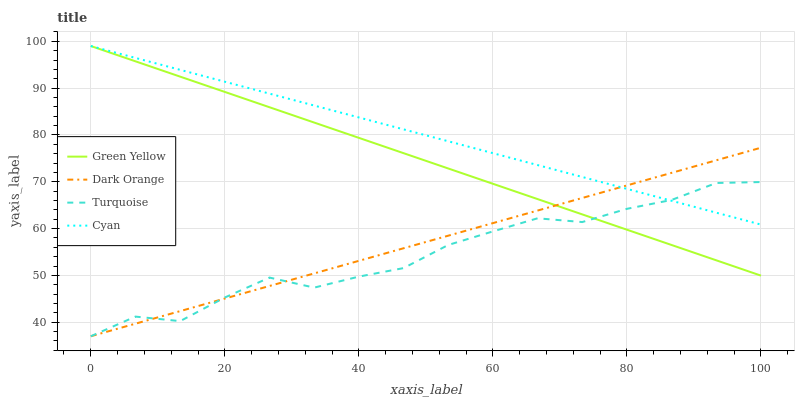Does Turquoise have the minimum area under the curve?
Answer yes or no. Yes. Does Cyan have the maximum area under the curve?
Answer yes or no. Yes. Does Green Yellow have the minimum area under the curve?
Answer yes or no. No. Does Green Yellow have the maximum area under the curve?
Answer yes or no. No. Is Green Yellow the smoothest?
Answer yes or no. Yes. Is Turquoise the roughest?
Answer yes or no. Yes. Is Turquoise the smoothest?
Answer yes or no. No. Is Green Yellow the roughest?
Answer yes or no. No. Does Dark Orange have the lowest value?
Answer yes or no. Yes. Does Green Yellow have the lowest value?
Answer yes or no. No. Does Cyan have the highest value?
Answer yes or no. Yes. Does Turquoise have the highest value?
Answer yes or no. No. Does Dark Orange intersect Green Yellow?
Answer yes or no. Yes. Is Dark Orange less than Green Yellow?
Answer yes or no. No. Is Dark Orange greater than Green Yellow?
Answer yes or no. No. 